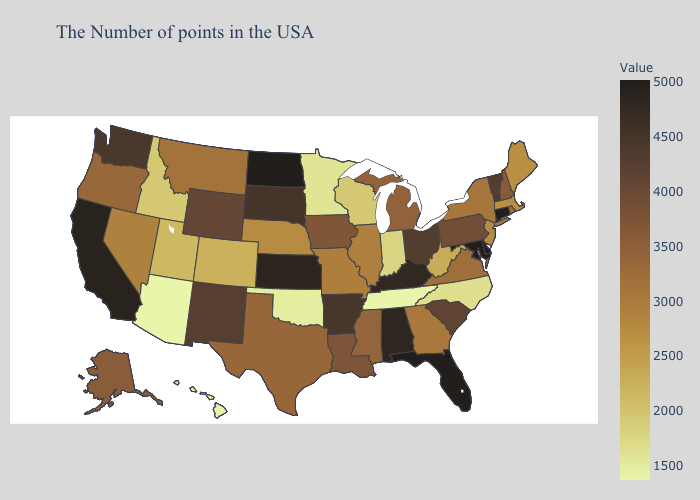Does New Jersey have the highest value in the USA?
Answer briefly. No. Does Iowa have the lowest value in the USA?
Give a very brief answer. No. Among the states that border Ohio , does West Virginia have the lowest value?
Write a very short answer. No. Is the legend a continuous bar?
Concise answer only. Yes. Does Tennessee have the highest value in the USA?
Be succinct. No. 